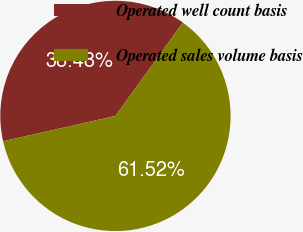<chart> <loc_0><loc_0><loc_500><loc_500><pie_chart><fcel>Operated well count basis<fcel>Operated sales volume basis<nl><fcel>38.48%<fcel>61.52%<nl></chart> 